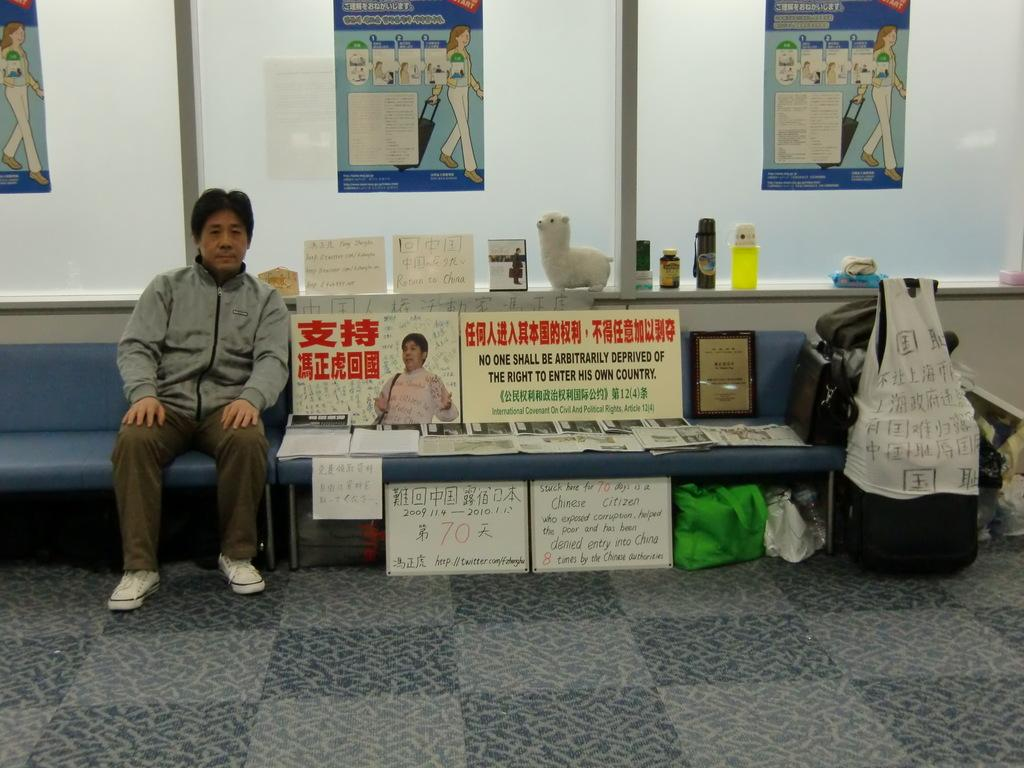What can be seen hanging on the walls in the image? There are posters in the image. Where is the person located in the image? The person is sitting on a bench on the left side of the image. What is located on the right side of the image? There is luggage on the right side of the image. What flavor of sheep can be seen grazing on the coast in the image? There are no sheep or coast present in the image; it features posters, a person sitting on a bench, and luggage. 